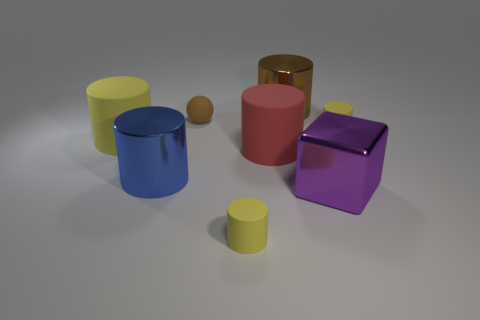What materials appear to be represented by the objects in the image? The objects in the image seem to represent various materials. The cylinders and the cube exhibit a shiny surface, suggesting they are made of metal, whereas the object with a red color and matte finish appears to be made of rubber. 